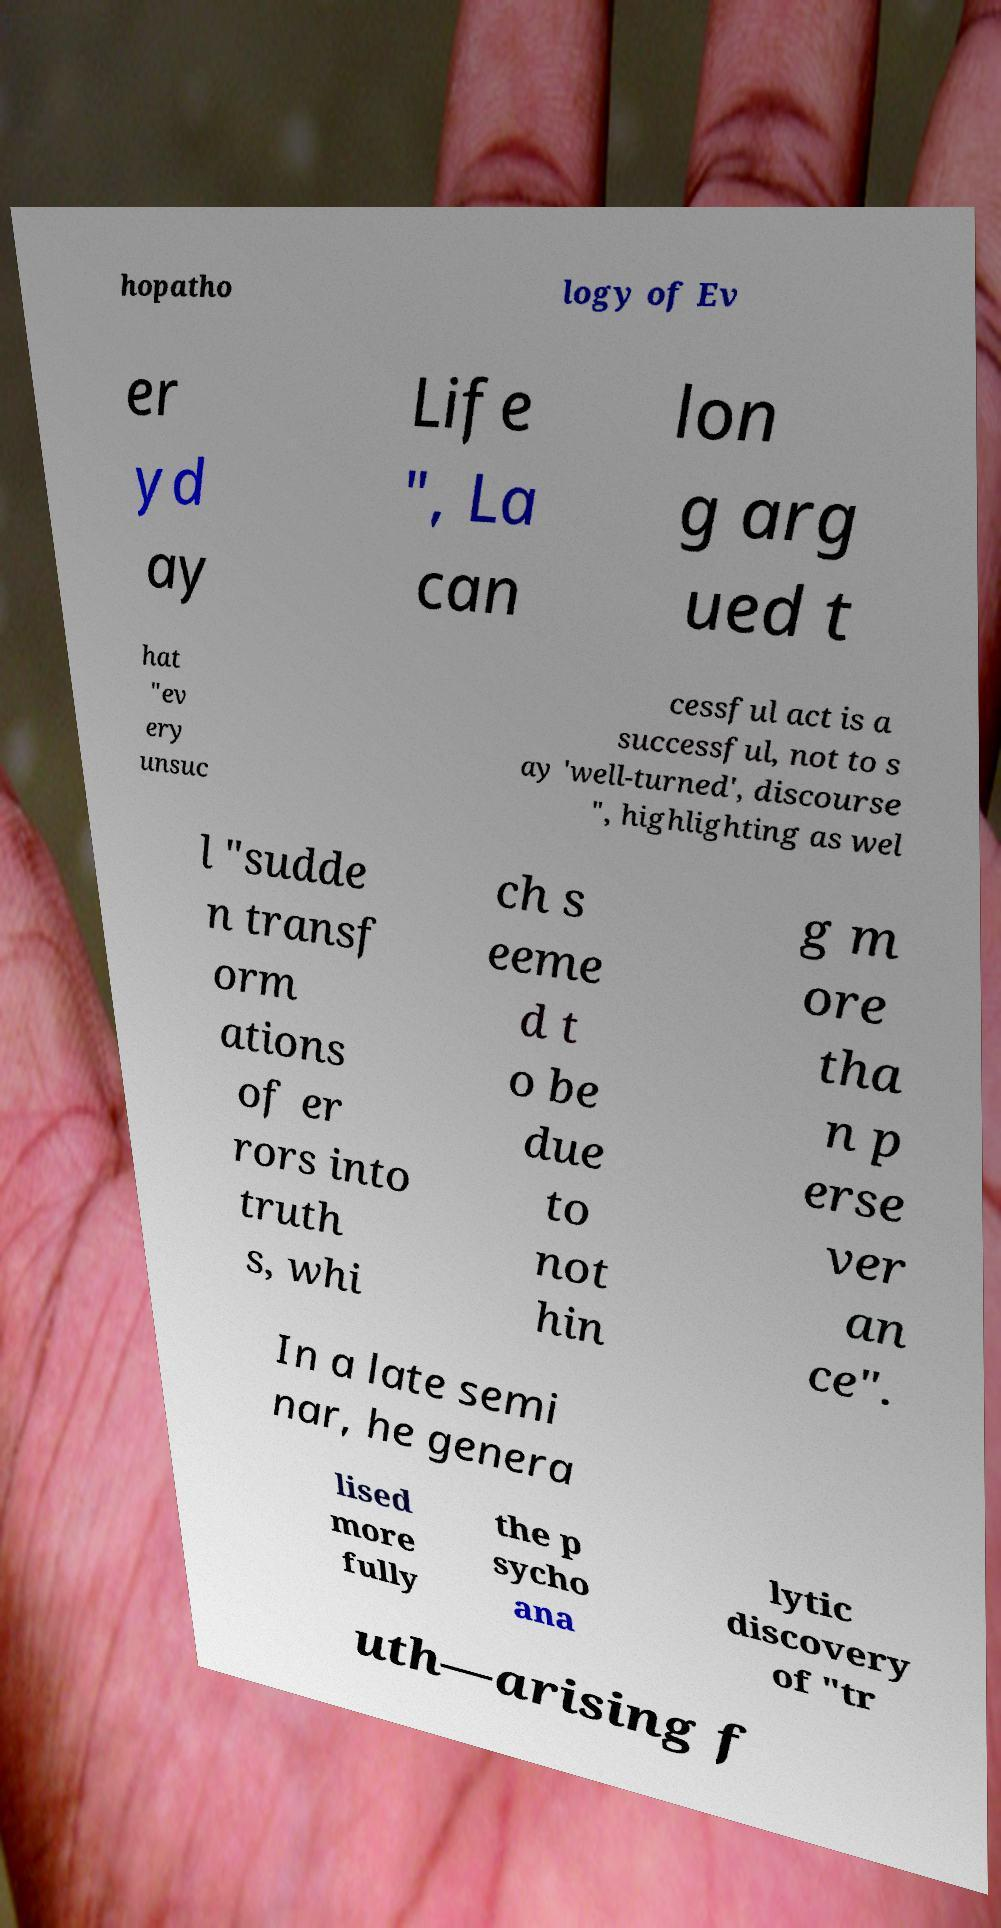Can you accurately transcribe the text from the provided image for me? hopatho logy of Ev er yd ay Life ", La can lon g arg ued t hat "ev ery unsuc cessful act is a successful, not to s ay 'well-turned', discourse ", highlighting as wel l "sudde n transf orm ations of er rors into truth s, whi ch s eeme d t o be due to not hin g m ore tha n p erse ver an ce". In a late semi nar, he genera lised more fully the p sycho ana lytic discovery of "tr uth—arising f 